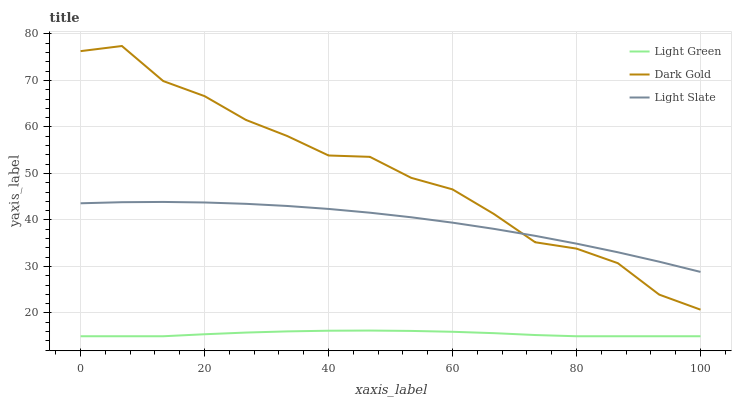Does Light Green have the minimum area under the curve?
Answer yes or no. Yes. Does Dark Gold have the maximum area under the curve?
Answer yes or no. Yes. Does Dark Gold have the minimum area under the curve?
Answer yes or no. No. Does Light Green have the maximum area under the curve?
Answer yes or no. No. Is Light Green the smoothest?
Answer yes or no. Yes. Is Dark Gold the roughest?
Answer yes or no. Yes. Is Dark Gold the smoothest?
Answer yes or no. No. Is Light Green the roughest?
Answer yes or no. No. Does Light Green have the lowest value?
Answer yes or no. Yes. Does Dark Gold have the lowest value?
Answer yes or no. No. Does Dark Gold have the highest value?
Answer yes or no. Yes. Does Light Green have the highest value?
Answer yes or no. No. Is Light Green less than Light Slate?
Answer yes or no. Yes. Is Dark Gold greater than Light Green?
Answer yes or no. Yes. Does Dark Gold intersect Light Slate?
Answer yes or no. Yes. Is Dark Gold less than Light Slate?
Answer yes or no. No. Is Dark Gold greater than Light Slate?
Answer yes or no. No. Does Light Green intersect Light Slate?
Answer yes or no. No. 